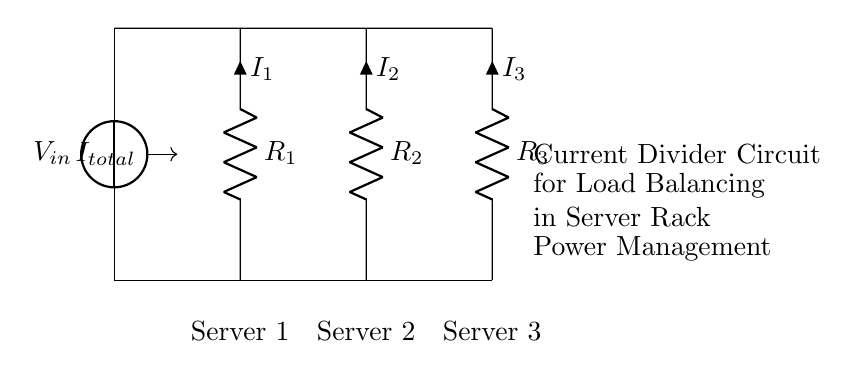What is the input voltage of this circuit? The input voltage is annotated as V_in in the circuit diagram, represented by the voltage source on the left side.
Answer: V_in How many resistors are in the circuit? There are three resistors in the circuit, labeled R_1, R_2, and R_3, which are shown connected in parallel to constitute the current divider setup.
Answer: 3 What is the purpose of this circuit? The purpose of this circuit is to balance the load across multiple servers by dividing the current into three paths, each going to a different server in a server rack setup.
Answer: Load balancing Which server is connected to resistor R_2? Resistor R_2 directly connects to Server 2, as indicated by the labeling in the circuit diagram.
Answer: Server 2 What current flows through resistor R_3? The current flowing through R_3 is labeled as I_3 in the circuit diagram, which is within the connected branch leading to Server 3.
Answer: I_3 What type of circuit is this? This is a current divider circuit, characterized by the parallel arrangement of resistors that allows for the division of input current among the branches leading to various loads.
Answer: Current divider If the total current into the circuit is I_total, how is it distributed among the resistors? The total current I_total divides between the resistors based on their resistance values, where the current for each branch follows the principle of inverse proportionality to their resistances.
Answer: Based on resistance 